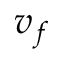<formula> <loc_0><loc_0><loc_500><loc_500>v _ { f }</formula> 